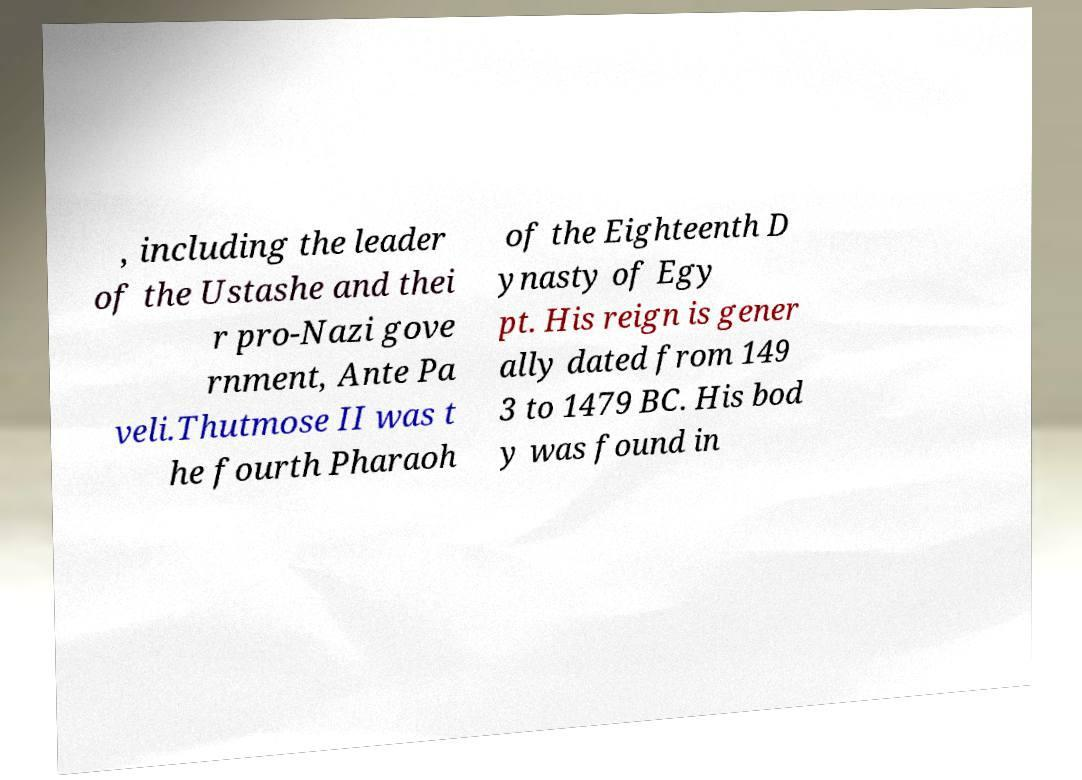Could you extract and type out the text from this image? , including the leader of the Ustashe and thei r pro-Nazi gove rnment, Ante Pa veli.Thutmose II was t he fourth Pharaoh of the Eighteenth D ynasty of Egy pt. His reign is gener ally dated from 149 3 to 1479 BC. His bod y was found in 